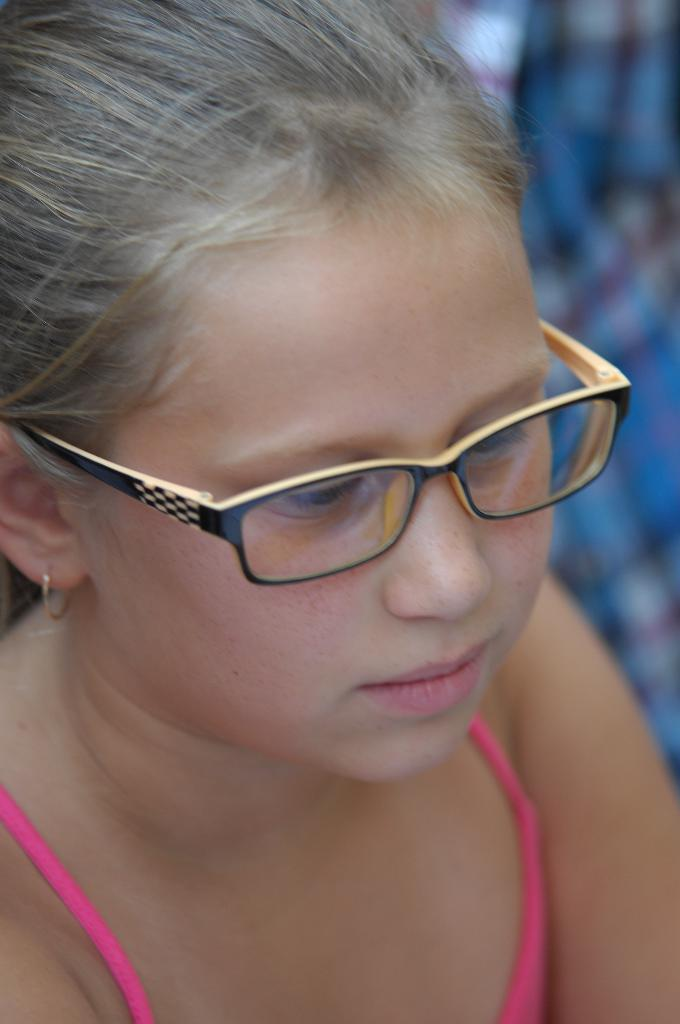Who is the main subject in the picture? There is a small girl in the picture. What is the girl wearing that is noticeable? The girl is wearing glasses (specs). Where is the girl positioned in the image? The girl is sitting in the front. How would you describe the background of the image? The background of the image is blurred. How many pages does the girl have in her hand in the image? There is no indication in the image that the girl is holding any pages or a book. 